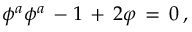Convert formula to latex. <formula><loc_0><loc_0><loc_500><loc_500>\phi ^ { a } \phi ^ { a } \, - 1 \, + \, 2 \varphi \, = \, 0 \, ,</formula> 